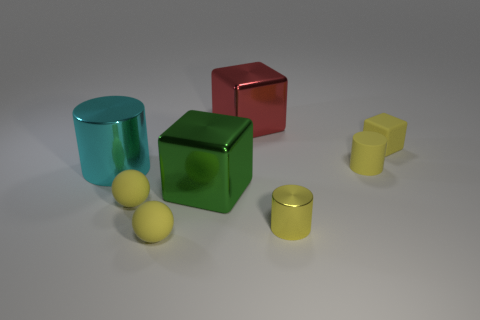Add 2 red blocks. How many objects exist? 10 Subtract all cylinders. How many objects are left? 5 Add 4 large cyan metal cylinders. How many large cyan metal cylinders exist? 5 Subtract 0 blue cylinders. How many objects are left? 8 Subtract all blocks. Subtract all small yellow metal cylinders. How many objects are left? 4 Add 1 big cyan shiny objects. How many big cyan shiny objects are left? 2 